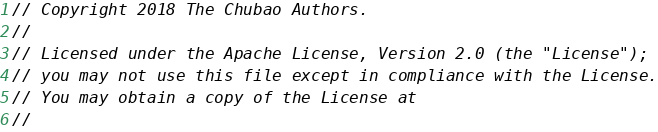Convert code to text. <code><loc_0><loc_0><loc_500><loc_500><_Go_>// Copyright 2018 The Chubao Authors.
//
// Licensed under the Apache License, Version 2.0 (the "License");
// you may not use this file except in compliance with the License.
// You may obtain a copy of the License at
//</code> 